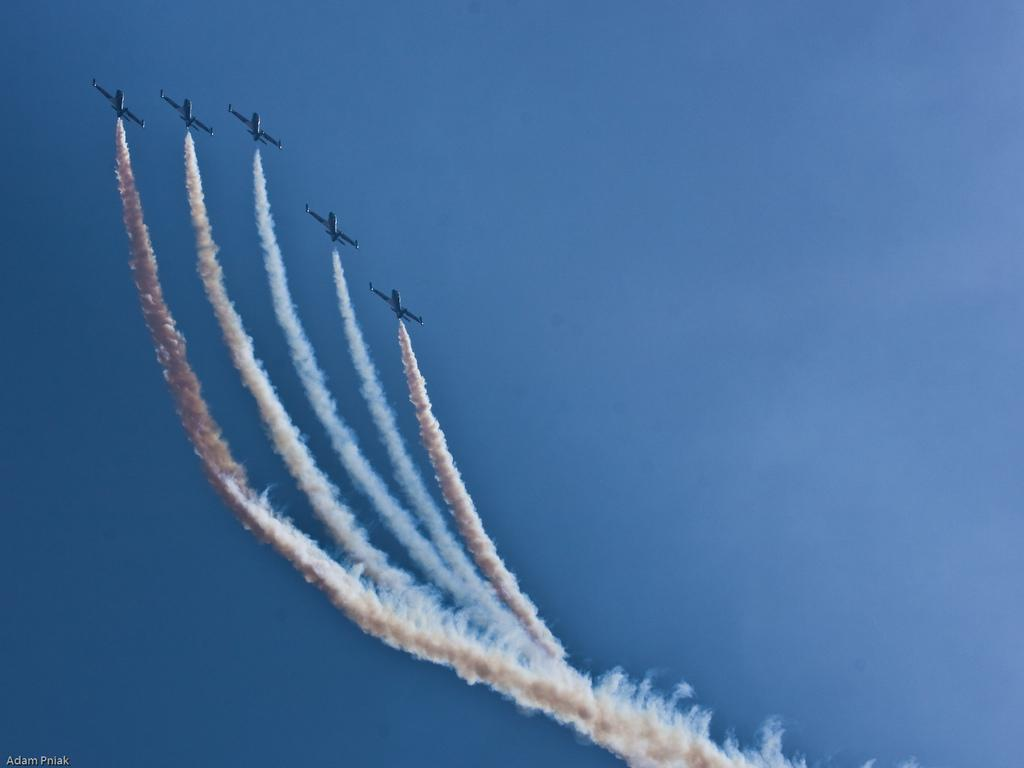What type of vehicles are present in the image? There are jet planes in the image. What action are the jet planes performing? The jet planes are releasing smoke. Where is the smoke visible in the image? The smoke is visible in the sky. What type of spark can be seen coming from the jet planes in the image? There is no spark visible in the image; the jet planes are releasing smoke. 